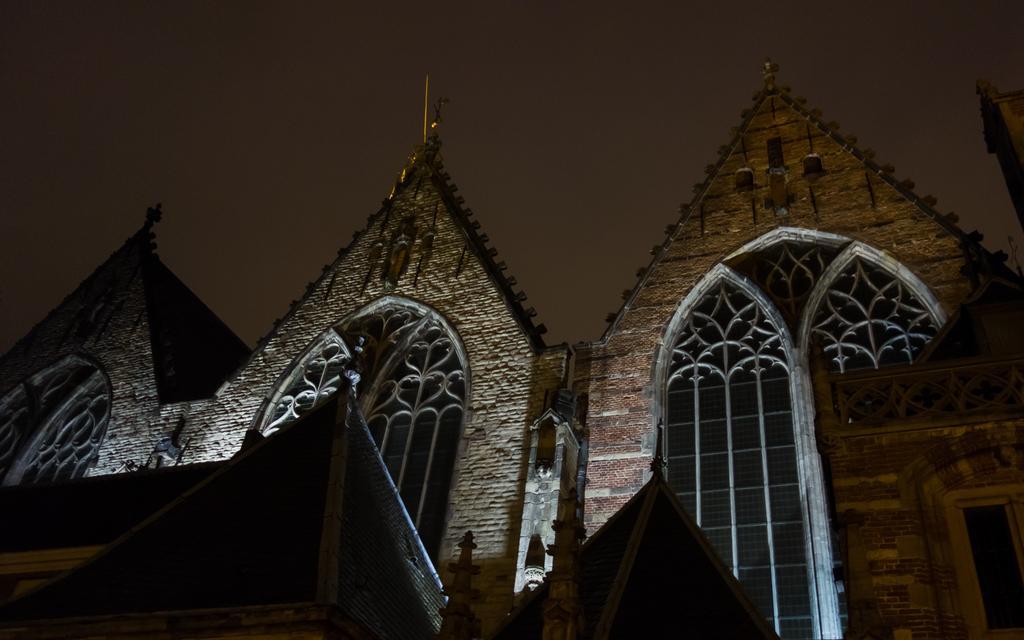Could you give a brief overview of what you see in this image? In this image there is the sky towards the top of the image, there is a building towards the bottom of the image, there is a wall. 